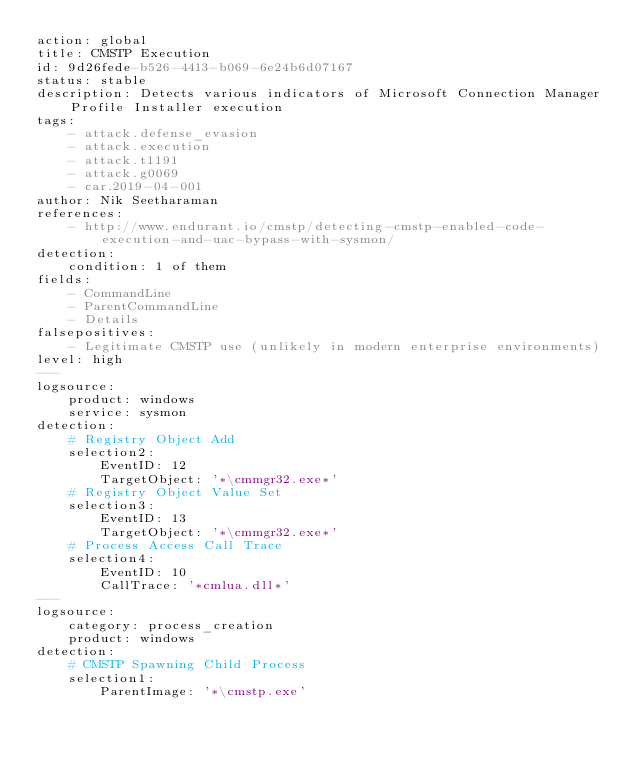Convert code to text. <code><loc_0><loc_0><loc_500><loc_500><_YAML_>action: global
title: CMSTP Execution
id: 9d26fede-b526-4413-b069-6e24b6d07167
status: stable
description: Detects various indicators of Microsoft Connection Manager Profile Installer execution
tags:
    - attack.defense_evasion
    - attack.execution
    - attack.t1191
    - attack.g0069
    - car.2019-04-001
author: Nik Seetharaman
references:
    - http://www.endurant.io/cmstp/detecting-cmstp-enabled-code-execution-and-uac-bypass-with-sysmon/
detection:
    condition: 1 of them
fields:
    - CommandLine
    - ParentCommandLine
    - Details
falsepositives:
    - Legitimate CMSTP use (unlikely in modern enterprise environments)
level: high
---
logsource:
    product: windows
    service: sysmon
detection:
    # Registry Object Add
    selection2:
        EventID: 12
        TargetObject: '*\cmmgr32.exe*'
    # Registry Object Value Set
    selection3:
        EventID: 13
        TargetObject: '*\cmmgr32.exe*'
    # Process Access Call Trace
    selection4:
        EventID: 10
        CallTrace: '*cmlua.dll*'
---
logsource:
    category: process_creation
    product: windows
detection:
    # CMSTP Spawning Child Process
    selection1:
        ParentImage: '*\cmstp.exe'</code> 